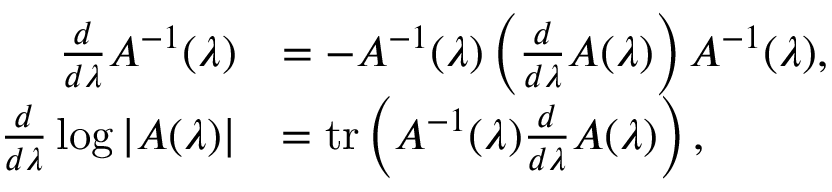<formula> <loc_0><loc_0><loc_500><loc_500>\begin{array} { r l } { \frac { d } { d \lambda } A ^ { - 1 } ( \lambda ) } & { = - A ^ { - 1 } ( \lambda ) \left ( \frac { d } { d \lambda } A ( \lambda ) \right ) A ^ { - 1 } ( \lambda ) , } \\ { \frac { d } { d \lambda } \log | A ( \lambda ) | } & { = t r \left ( A ^ { - 1 } ( \lambda ) \frac { d } { d \lambda } A ( \lambda ) \right ) , } \end{array}</formula> 